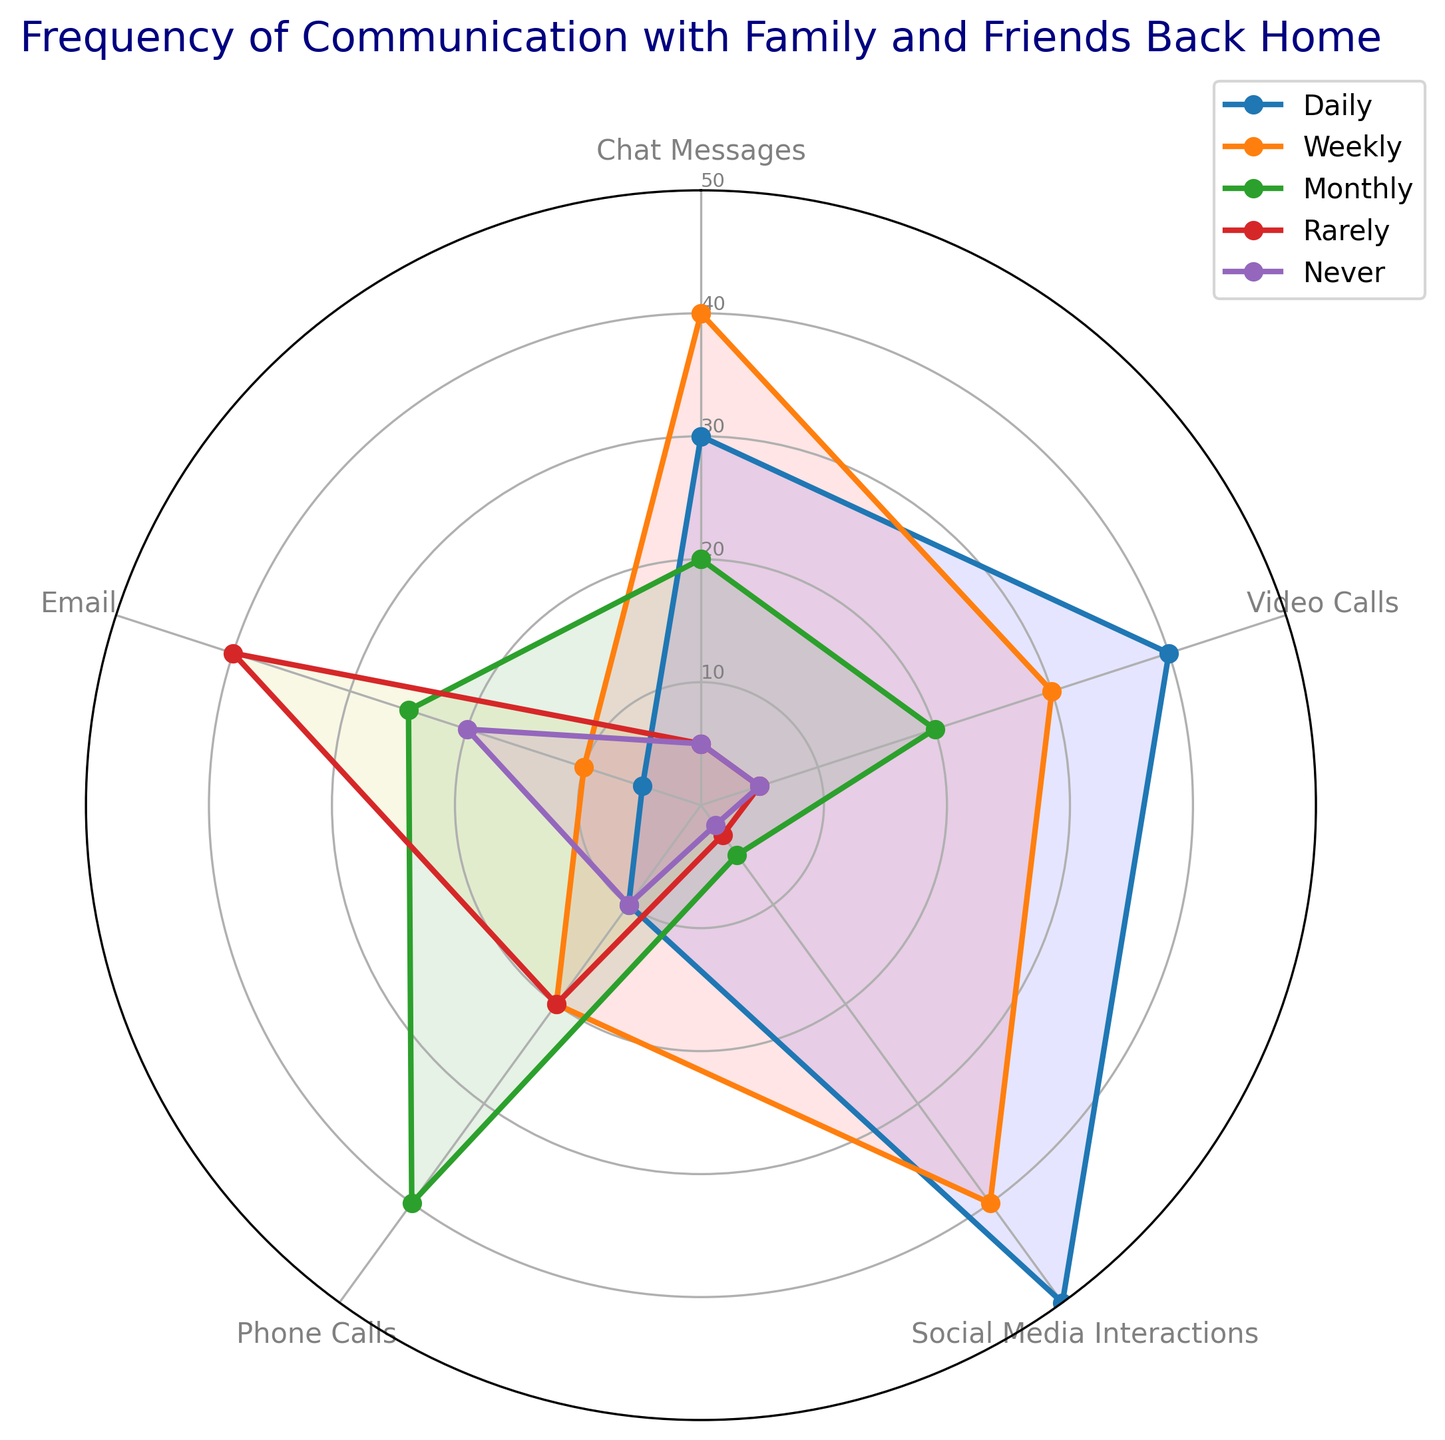Which communication method is used the most daily? The chart shows that 'Social Media Interactions' has the highest value at 50 in the daily category.
Answer: Social Media Interactions Which communication method is least used for weekly interactions? The chart shows that 'Email' has the lowest value at 10 in the weekly category.
Answer: Email Are there any communication methods where the frequency of usage is equal for any two categories? If so, which methods and categories? The chart shows that 'Chat Messages', 'Video Calls', and 'Phone Calls' all have an equal frequency of 5 for daily and rarely interaction categories.
Answer: Chat Messages, Video Calls, Phone Calls - daily and rarely Which two communication methods have the most significant difference in the 'monthly' usage category? The chart shows that 'Phone Calls' has a value of 40 and 'Social Media Interactions' has a value of 5, which results in the most significant difference of 35.
Answer: Phone Calls and Social Media Interactions What's the average usage frequency for 'Email' across all categories? The values for Email are (5, 10, 25, 40, 20). The total sum is 100, with 5 categories. The average is 100/5 = 20.
Answer: 20 Which category has the highest variability in frequency between different communication methods? By observing the spread of values in each category, 'Daily' has the most variability, with values ranging from 5 to 50.
Answer: Daily Which communication method has the smallest total sum of usage across all categories? Summing up all categories for each method shows 'Email' has the smallest total sum: 5+10+25+40+20 = 100.
Answer: Email Is there any overlap in frequency values between 'Phone Calls' and 'Video Calls' for any category? The chart shows both 'Phone Calls' and 'Video Calls' each have frequencies of 20 in the weekly category.
Answer: Yes Which category shows the highest frequency of usage for 'Video Calls'? The chart shows that 'Video Calls' has the highest value in the daily category, which is 40.
Answer: Daily 